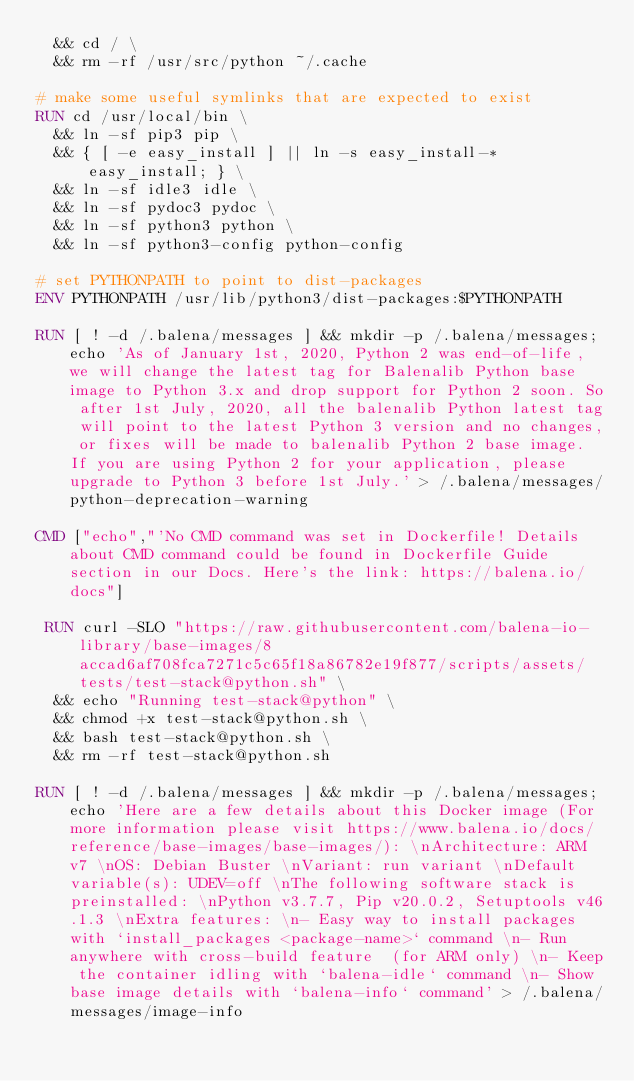Convert code to text. <code><loc_0><loc_0><loc_500><loc_500><_Dockerfile_>	&& cd / \
	&& rm -rf /usr/src/python ~/.cache

# make some useful symlinks that are expected to exist
RUN cd /usr/local/bin \
	&& ln -sf pip3 pip \
	&& { [ -e easy_install ] || ln -s easy_install-* easy_install; } \
	&& ln -sf idle3 idle \
	&& ln -sf pydoc3 pydoc \
	&& ln -sf python3 python \
	&& ln -sf python3-config python-config

# set PYTHONPATH to point to dist-packages
ENV PYTHONPATH /usr/lib/python3/dist-packages:$PYTHONPATH

RUN [ ! -d /.balena/messages ] && mkdir -p /.balena/messages; echo 'As of January 1st, 2020, Python 2 was end-of-life, we will change the latest tag for Balenalib Python base image to Python 3.x and drop support for Python 2 soon. So after 1st July, 2020, all the balenalib Python latest tag will point to the latest Python 3 version and no changes, or fixes will be made to balenalib Python 2 base image. If you are using Python 2 for your application, please upgrade to Python 3 before 1st July.' > /.balena/messages/python-deprecation-warning

CMD ["echo","'No CMD command was set in Dockerfile! Details about CMD command could be found in Dockerfile Guide section in our Docs. Here's the link: https://balena.io/docs"]

 RUN curl -SLO "https://raw.githubusercontent.com/balena-io-library/base-images/8accad6af708fca7271c5c65f18a86782e19f877/scripts/assets/tests/test-stack@python.sh" \
  && echo "Running test-stack@python" \
  && chmod +x test-stack@python.sh \
  && bash test-stack@python.sh \
  && rm -rf test-stack@python.sh 

RUN [ ! -d /.balena/messages ] && mkdir -p /.balena/messages; echo 'Here are a few details about this Docker image (For more information please visit https://www.balena.io/docs/reference/base-images/base-images/): \nArchitecture: ARM v7 \nOS: Debian Buster \nVariant: run variant \nDefault variable(s): UDEV=off \nThe following software stack is preinstalled: \nPython v3.7.7, Pip v20.0.2, Setuptools v46.1.3 \nExtra features: \n- Easy way to install packages with `install_packages <package-name>` command \n- Run anywhere with cross-build feature  (for ARM only) \n- Keep the container idling with `balena-idle` command \n- Show base image details with `balena-info` command' > /.balena/messages/image-info
</code> 